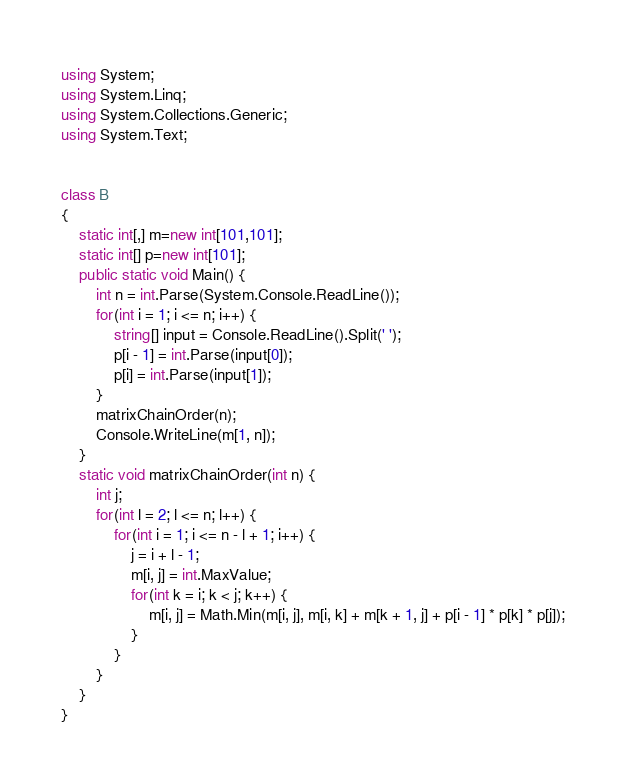Convert code to text. <code><loc_0><loc_0><loc_500><loc_500><_C#_>using System;
using System.Linq;
using System.Collections.Generic;
using System.Text;


class B
{
    static int[,] m=new int[101,101];
    static int[] p=new int[101];
    public static void Main() {
        int n = int.Parse(System.Console.ReadLine());
        for(int i = 1; i <= n; i++) {
            string[] input = Console.ReadLine().Split(' ');
            p[i - 1] = int.Parse(input[0]);
            p[i] = int.Parse(input[1]);
        }
        matrixChainOrder(n);
        Console.WriteLine(m[1, n]);
    }
    static void matrixChainOrder(int n) {
        int j;
        for(int l = 2; l <= n; l++) {
            for(int i = 1; i <= n - l + 1; i++) {
                j = i + l - 1;
                m[i, j] = int.MaxValue;
                for(int k = i; k < j; k++) {
                    m[i, j] = Math.Min(m[i, j], m[i, k] + m[k + 1, j] + p[i - 1] * p[k] * p[j]);
                }
            }
        }
    }
}
</code> 